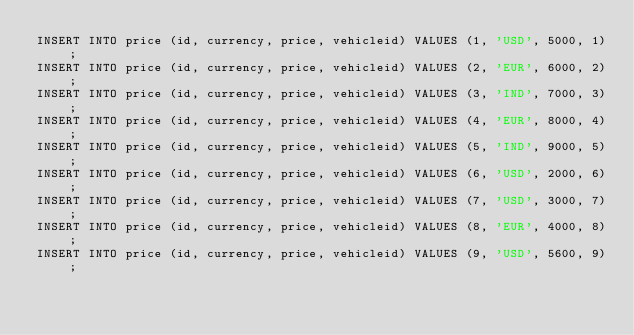<code> <loc_0><loc_0><loc_500><loc_500><_SQL_>INSERT INTO price (id, currency, price, vehicleid) VALUES (1, 'USD', 5000, 1);
INSERT INTO price (id, currency, price, vehicleid) VALUES (2, 'EUR', 6000, 2);
INSERT INTO price (id, currency, price, vehicleid) VALUES (3, 'IND', 7000, 3);
INSERT INTO price (id, currency, price, vehicleid) VALUES (4, 'EUR', 8000, 4);
INSERT INTO price (id, currency, price, vehicleid) VALUES (5, 'IND', 9000, 5);
INSERT INTO price (id, currency, price, vehicleid) VALUES (6, 'USD', 2000, 6);
INSERT INTO price (id, currency, price, vehicleid) VALUES (7, 'USD', 3000, 7);
INSERT INTO price (id, currency, price, vehicleid) VALUES (8, 'EUR', 4000, 8);
INSERT INTO price (id, currency, price, vehicleid) VALUES (9, 'USD', 5600, 9);</code> 